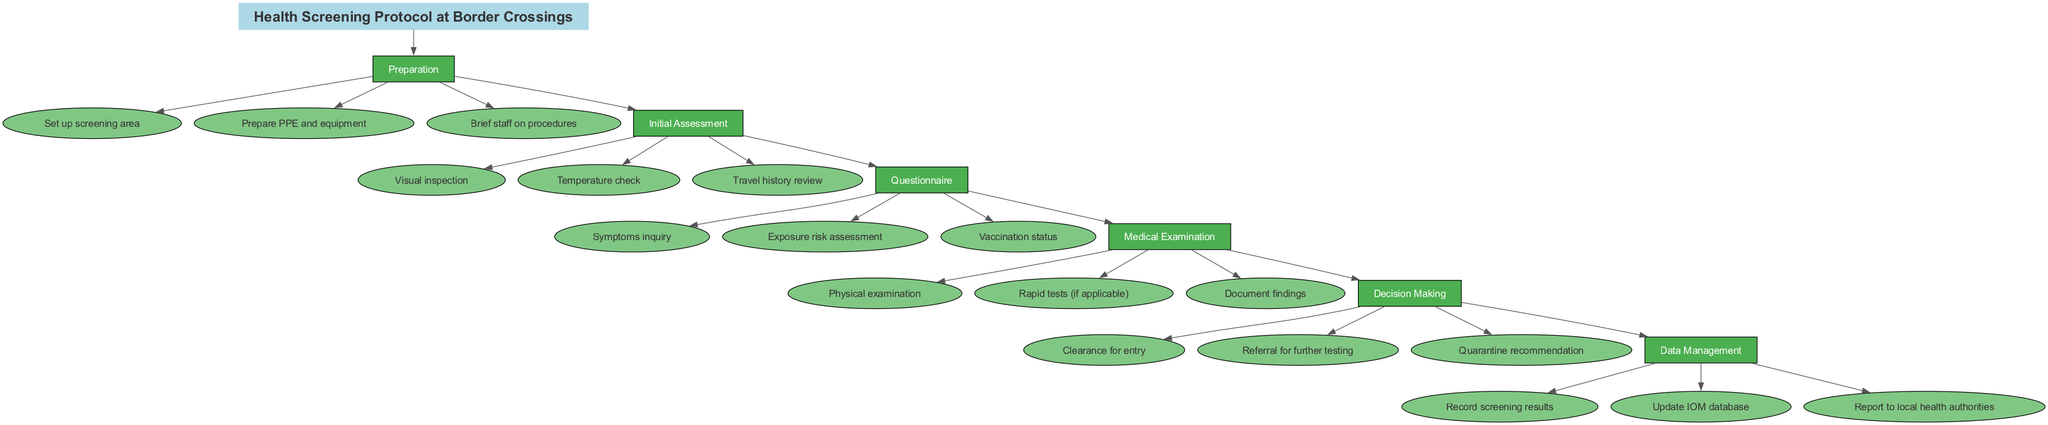What is the first step in the health screening protocol? The first step is indicated at the top of the diagram under the "steps" section, which shows "Preparation" as the first step.
Answer: Preparation How many items are listed under the "Initial Assessment" step? By examining the items listed under "Initial Assessment," we see three distinct items: "Visual inspection," "Temperature check," and "Travel history review," making the total count three.
Answer: 3 What follows the "Medical Examination" step? In the diagram, the "Decision Making" step comes directly after the "Medical Examination," as the edges connecting the nodes show the flow of the protocol.
Answer: Decision Making What is the last item listed in the "Data Management" step? The last item in the "Data Management" step is indicated in the diagram as "Report to local health authorities," which is shown clearly as part of that step.
Answer: Report to local health authorities How many total steps are there in the health screening protocol? The total number of steps can be counted from the listed steps in the diagram, which are six: Preparation, Initial Assessment, Questionnaire, Medical Examination, Decision Making, and Data Management.
Answer: 6 What type of examination occurs during the "Medical Examination" step? The "Medical Examination" includes a Physical examination, which is specifically mentioned as one of the items under this step in the diagram.
Answer: Physical examination Which step involves assessing symptoms and exposure risks? The "Questionnaire" step is indicated to involve inquiries about symptoms and exposure risk assessments, as outlined in the items under that step.
Answer: Questionnaire What color are the item nodes in the diagram? The item nodes are filled with the color light green, specifically the hex color code #81C784, as indicated in the attributes set for the nodes in the diagram.
Answer: Light green 